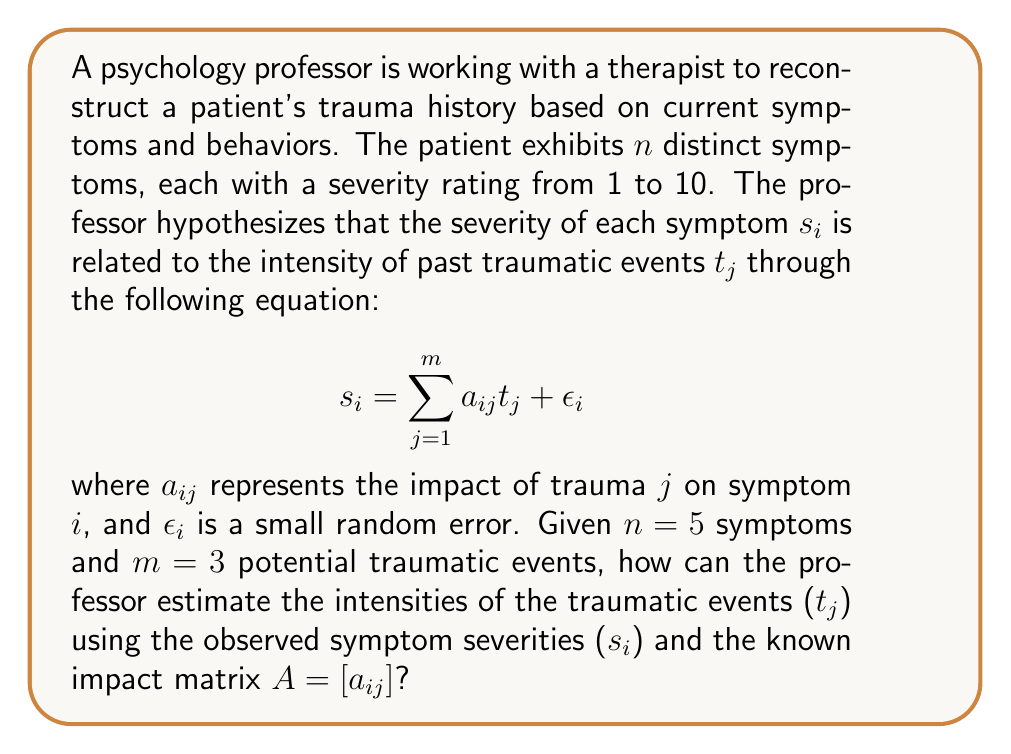What is the answer to this math problem? To solve this inverse problem and reconstruct the patient's trauma history, we can use the least squares method. Here's a step-by-step approach:

1) First, we can represent the problem in matrix form:

   $$S = AT + E$$

   where $S$ is the $n \times 1$ vector of symptom severities, $A$ is the $n \times m$ matrix of impact factors, $T$ is the $m \times 1$ vector of trauma intensities we want to estimate, and $E$ is the $n \times 1$ vector of errors.

2) The least squares solution minimizes the sum of squared errors. The estimator $\hat{T}$ is given by:

   $$\hat{T} = (A^T A)^{-1} A^T S$$

3) To compute this:
   a) Calculate $A^T A$ (an $m \times m$ matrix)
   b) Find $(A^T A)^{-1}$
   c) Multiply $(A^T A)^{-1}$ by $A^T$
   d) Finally, multiply the result by $S$

4) The resulting $\hat{T}$ vector will contain the estimated intensities of the three traumatic events.

5) To assess the quality of the reconstruction, we can:
   a) Calculate the predicted symptoms: $\hat{S} = A\hat{T}$
   b) Compute the residuals: $E = S - \hat{S}$
   c) Calculate the coefficient of determination, $R^2$:
      $$R^2 = 1 - \frac{\sum_{i=1}^n (s_i - \hat{s}_i)^2}{\sum_{i=1}^n (s_i - \bar{s})^2}$$
      where $\bar{s}$ is the mean of the observed symptom severities.

6) The $R^2$ value will indicate how well the model fits the data, with values closer to 1 indicating a better fit.
Answer: $\hat{T} = (A^T A)^{-1} A^T S$ 